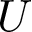Convert formula to latex. <formula><loc_0><loc_0><loc_500><loc_500>U</formula> 